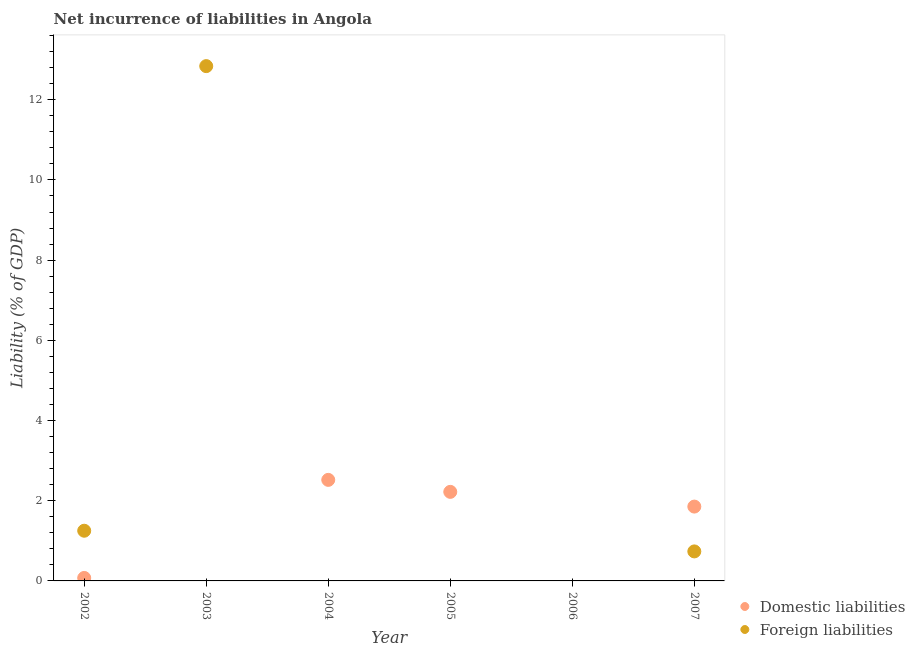How many different coloured dotlines are there?
Offer a terse response. 2. What is the incurrence of domestic liabilities in 2005?
Provide a short and direct response. 2.22. Across all years, what is the maximum incurrence of foreign liabilities?
Make the answer very short. 12.84. Across all years, what is the minimum incurrence of domestic liabilities?
Your answer should be compact. 0. In which year was the incurrence of domestic liabilities maximum?
Make the answer very short. 2004. What is the total incurrence of domestic liabilities in the graph?
Give a very brief answer. 6.67. What is the difference between the incurrence of foreign liabilities in 2002 and that in 2007?
Give a very brief answer. 0.52. What is the difference between the incurrence of foreign liabilities in 2003 and the incurrence of domestic liabilities in 2005?
Offer a terse response. 10.62. What is the average incurrence of domestic liabilities per year?
Make the answer very short. 1.11. In the year 2007, what is the difference between the incurrence of domestic liabilities and incurrence of foreign liabilities?
Offer a terse response. 1.12. What is the ratio of the incurrence of foreign liabilities in 2002 to that in 2007?
Provide a short and direct response. 1.7. Is the incurrence of domestic liabilities in 2002 less than that in 2005?
Provide a succinct answer. Yes. What is the difference between the highest and the second highest incurrence of foreign liabilities?
Provide a short and direct response. 11.59. What is the difference between the highest and the lowest incurrence of foreign liabilities?
Ensure brevity in your answer.  12.84. Is the sum of the incurrence of foreign liabilities in 2002 and 2003 greater than the maximum incurrence of domestic liabilities across all years?
Ensure brevity in your answer.  Yes. Does the incurrence of domestic liabilities monotonically increase over the years?
Provide a short and direct response. No. Is the incurrence of domestic liabilities strictly less than the incurrence of foreign liabilities over the years?
Give a very brief answer. No. How many years are there in the graph?
Your answer should be very brief. 6. Are the values on the major ticks of Y-axis written in scientific E-notation?
Offer a terse response. No. Does the graph contain grids?
Offer a very short reply. No. How are the legend labels stacked?
Provide a succinct answer. Vertical. What is the title of the graph?
Offer a very short reply. Net incurrence of liabilities in Angola. Does "Rural Population" appear as one of the legend labels in the graph?
Provide a succinct answer. No. What is the label or title of the Y-axis?
Keep it short and to the point. Liability (% of GDP). What is the Liability (% of GDP) in Domestic liabilities in 2002?
Give a very brief answer. 0.07. What is the Liability (% of GDP) in Foreign liabilities in 2002?
Give a very brief answer. 1.25. What is the Liability (% of GDP) in Foreign liabilities in 2003?
Provide a short and direct response. 12.84. What is the Liability (% of GDP) in Domestic liabilities in 2004?
Offer a very short reply. 2.52. What is the Liability (% of GDP) of Foreign liabilities in 2004?
Make the answer very short. 0. What is the Liability (% of GDP) of Domestic liabilities in 2005?
Your answer should be compact. 2.22. What is the Liability (% of GDP) in Domestic liabilities in 2006?
Keep it short and to the point. 0. What is the Liability (% of GDP) of Domestic liabilities in 2007?
Make the answer very short. 1.85. What is the Liability (% of GDP) of Foreign liabilities in 2007?
Provide a short and direct response. 0.74. Across all years, what is the maximum Liability (% of GDP) of Domestic liabilities?
Offer a terse response. 2.52. Across all years, what is the maximum Liability (% of GDP) of Foreign liabilities?
Make the answer very short. 12.84. Across all years, what is the minimum Liability (% of GDP) of Foreign liabilities?
Offer a very short reply. 0. What is the total Liability (% of GDP) in Domestic liabilities in the graph?
Offer a very short reply. 6.67. What is the total Liability (% of GDP) in Foreign liabilities in the graph?
Give a very brief answer. 14.83. What is the difference between the Liability (% of GDP) of Foreign liabilities in 2002 and that in 2003?
Your answer should be compact. -11.59. What is the difference between the Liability (% of GDP) of Domestic liabilities in 2002 and that in 2004?
Offer a very short reply. -2.45. What is the difference between the Liability (% of GDP) of Domestic liabilities in 2002 and that in 2005?
Offer a very short reply. -2.15. What is the difference between the Liability (% of GDP) in Domestic liabilities in 2002 and that in 2007?
Provide a succinct answer. -1.78. What is the difference between the Liability (% of GDP) in Foreign liabilities in 2002 and that in 2007?
Your response must be concise. 0.52. What is the difference between the Liability (% of GDP) in Foreign liabilities in 2003 and that in 2007?
Provide a succinct answer. 12.1. What is the difference between the Liability (% of GDP) of Domestic liabilities in 2004 and that in 2005?
Provide a short and direct response. 0.3. What is the difference between the Liability (% of GDP) of Domestic liabilities in 2004 and that in 2007?
Offer a terse response. 0.67. What is the difference between the Liability (% of GDP) of Domestic liabilities in 2005 and that in 2007?
Provide a succinct answer. 0.37. What is the difference between the Liability (% of GDP) in Domestic liabilities in 2002 and the Liability (% of GDP) in Foreign liabilities in 2003?
Your answer should be compact. -12.76. What is the difference between the Liability (% of GDP) of Domestic liabilities in 2002 and the Liability (% of GDP) of Foreign liabilities in 2007?
Your answer should be compact. -0.66. What is the difference between the Liability (% of GDP) in Domestic liabilities in 2004 and the Liability (% of GDP) in Foreign liabilities in 2007?
Make the answer very short. 1.78. What is the difference between the Liability (% of GDP) in Domestic liabilities in 2005 and the Liability (% of GDP) in Foreign liabilities in 2007?
Your response must be concise. 1.49. What is the average Liability (% of GDP) of Domestic liabilities per year?
Keep it short and to the point. 1.11. What is the average Liability (% of GDP) in Foreign liabilities per year?
Provide a succinct answer. 2.47. In the year 2002, what is the difference between the Liability (% of GDP) in Domestic liabilities and Liability (% of GDP) in Foreign liabilities?
Keep it short and to the point. -1.18. In the year 2007, what is the difference between the Liability (% of GDP) of Domestic liabilities and Liability (% of GDP) of Foreign liabilities?
Offer a very short reply. 1.12. What is the ratio of the Liability (% of GDP) of Foreign liabilities in 2002 to that in 2003?
Provide a succinct answer. 0.1. What is the ratio of the Liability (% of GDP) in Domestic liabilities in 2002 to that in 2004?
Ensure brevity in your answer.  0.03. What is the ratio of the Liability (% of GDP) of Domestic liabilities in 2002 to that in 2005?
Offer a terse response. 0.03. What is the ratio of the Liability (% of GDP) in Domestic liabilities in 2002 to that in 2007?
Give a very brief answer. 0.04. What is the ratio of the Liability (% of GDP) of Foreign liabilities in 2002 to that in 2007?
Your answer should be very brief. 1.7. What is the ratio of the Liability (% of GDP) in Foreign liabilities in 2003 to that in 2007?
Provide a short and direct response. 17.44. What is the ratio of the Liability (% of GDP) of Domestic liabilities in 2004 to that in 2005?
Make the answer very short. 1.13. What is the ratio of the Liability (% of GDP) in Domestic liabilities in 2004 to that in 2007?
Your response must be concise. 1.36. What is the ratio of the Liability (% of GDP) of Domestic liabilities in 2005 to that in 2007?
Provide a short and direct response. 1.2. What is the difference between the highest and the second highest Liability (% of GDP) in Domestic liabilities?
Your response must be concise. 0.3. What is the difference between the highest and the second highest Liability (% of GDP) of Foreign liabilities?
Keep it short and to the point. 11.59. What is the difference between the highest and the lowest Liability (% of GDP) of Domestic liabilities?
Your answer should be very brief. 2.52. What is the difference between the highest and the lowest Liability (% of GDP) of Foreign liabilities?
Offer a terse response. 12.84. 